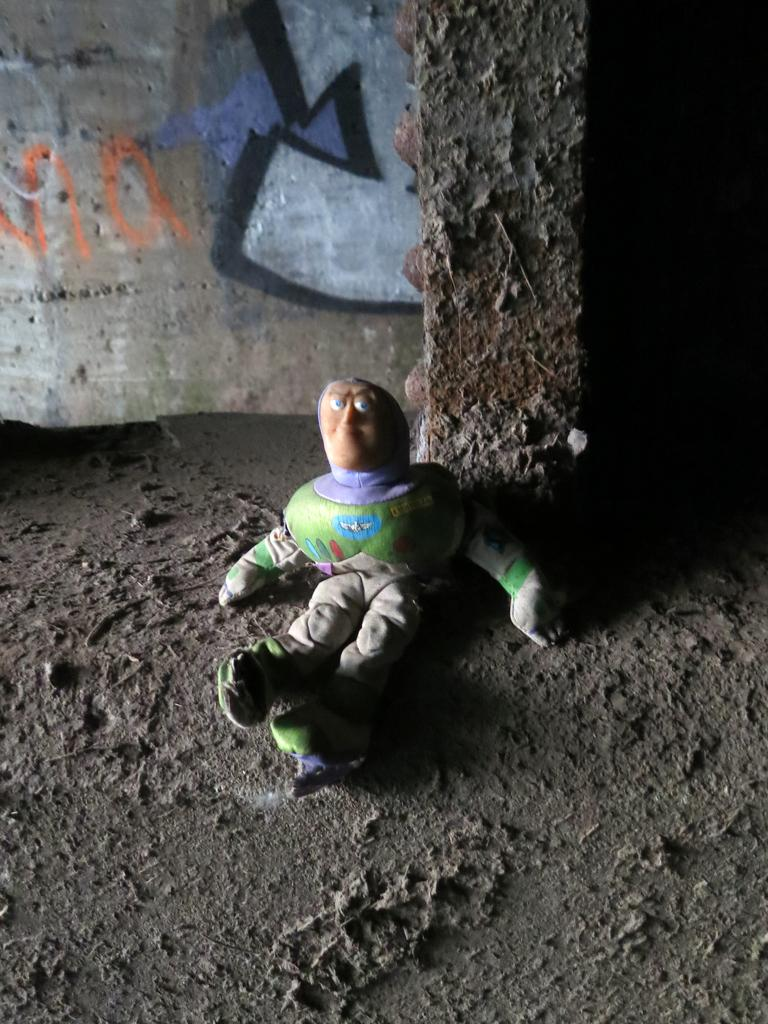What object can be seen in the image that is typically used for play? There is a toy in the image. What type of material is present in the image that is often found at beaches? There is sand in the image. What architectural feature can be seen in the image? There is a pillar in the image. What can be seen on the wall in the background of the image? There is a wall with text in the background of the image. What type of thread is used to create the bell in the image? There is no bell present in the image. What color is the underwear in the image? There is no underwear present in the image. 